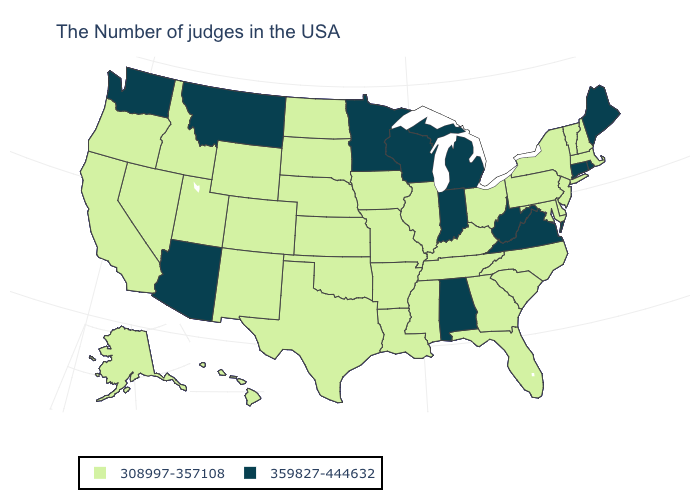Does Maine have the highest value in the Northeast?
Concise answer only. Yes. Does the first symbol in the legend represent the smallest category?
Keep it brief. Yes. Does Texas have the same value as Rhode Island?
Short answer required. No. What is the lowest value in states that border Utah?
Quick response, please. 308997-357108. What is the value of Oregon?
Write a very short answer. 308997-357108. What is the lowest value in states that border Arizona?
Be succinct. 308997-357108. Name the states that have a value in the range 308997-357108?
Give a very brief answer. Massachusetts, New Hampshire, Vermont, New York, New Jersey, Delaware, Maryland, Pennsylvania, North Carolina, South Carolina, Ohio, Florida, Georgia, Kentucky, Tennessee, Illinois, Mississippi, Louisiana, Missouri, Arkansas, Iowa, Kansas, Nebraska, Oklahoma, Texas, South Dakota, North Dakota, Wyoming, Colorado, New Mexico, Utah, Idaho, Nevada, California, Oregon, Alaska, Hawaii. Name the states that have a value in the range 359827-444632?
Short answer required. Maine, Rhode Island, Connecticut, Virginia, West Virginia, Michigan, Indiana, Alabama, Wisconsin, Minnesota, Montana, Arizona, Washington. Does South Carolina have the lowest value in the USA?
Concise answer only. Yes. What is the value of Kansas?
Answer briefly. 308997-357108. Name the states that have a value in the range 308997-357108?
Answer briefly. Massachusetts, New Hampshire, Vermont, New York, New Jersey, Delaware, Maryland, Pennsylvania, North Carolina, South Carolina, Ohio, Florida, Georgia, Kentucky, Tennessee, Illinois, Mississippi, Louisiana, Missouri, Arkansas, Iowa, Kansas, Nebraska, Oklahoma, Texas, South Dakota, North Dakota, Wyoming, Colorado, New Mexico, Utah, Idaho, Nevada, California, Oregon, Alaska, Hawaii. What is the highest value in the USA?
Quick response, please. 359827-444632. What is the value of Missouri?
Answer briefly. 308997-357108. What is the value of Alaska?
Concise answer only. 308997-357108. What is the value of Florida?
Be succinct. 308997-357108. 